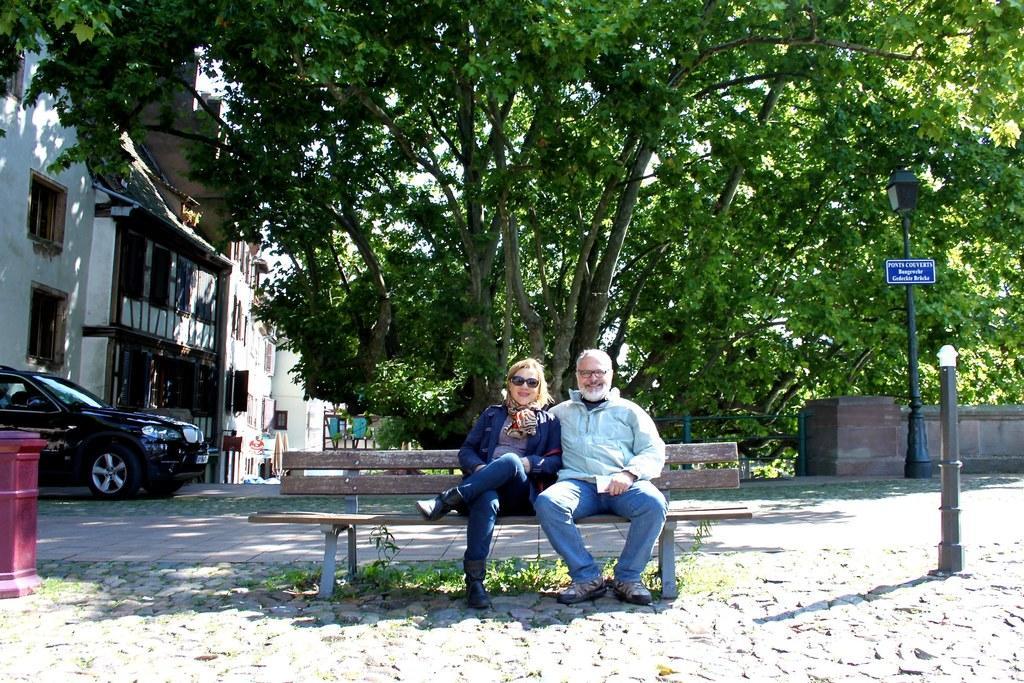Describe this image in one or two sentences. In the picture we can see a man and woman sitting on a bench just beside to them on the left hand side, there is a post box and there is board on right hand side. In the background we can find a tree, next to it there are buildings and a car and we can find some grass on the floor. 